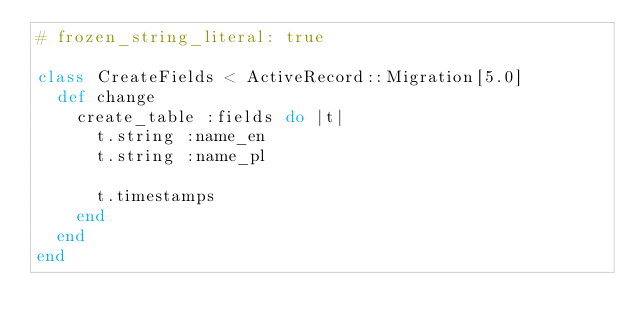Convert code to text. <code><loc_0><loc_0><loc_500><loc_500><_Ruby_># frozen_string_literal: true

class CreateFields < ActiveRecord::Migration[5.0]
  def change
    create_table :fields do |t|
      t.string :name_en
      t.string :name_pl

      t.timestamps
    end
  end
end
</code> 